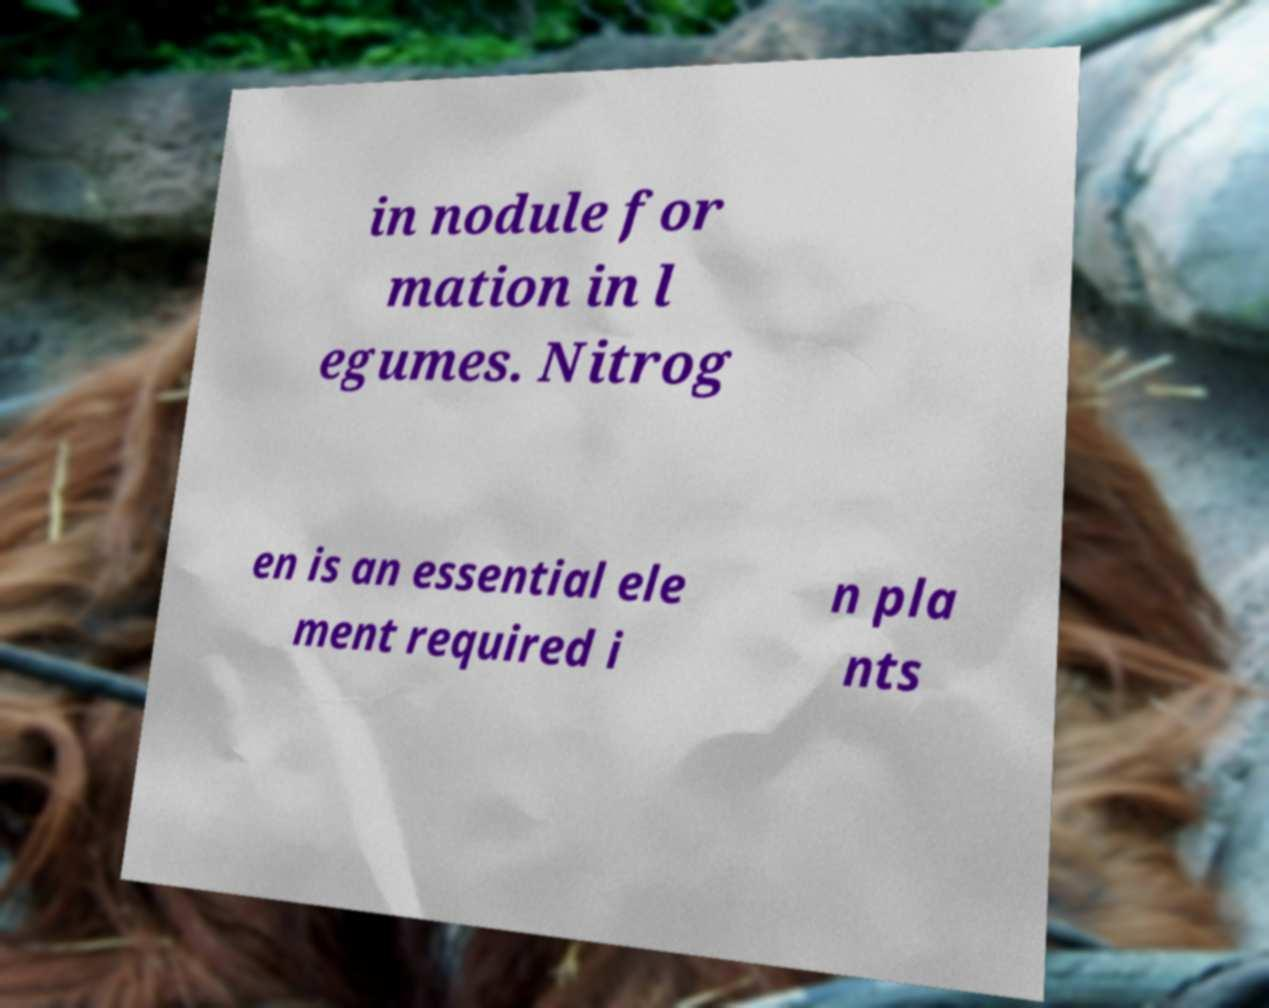What messages or text are displayed in this image? I need them in a readable, typed format. in nodule for mation in l egumes. Nitrog en is an essential ele ment required i n pla nts 